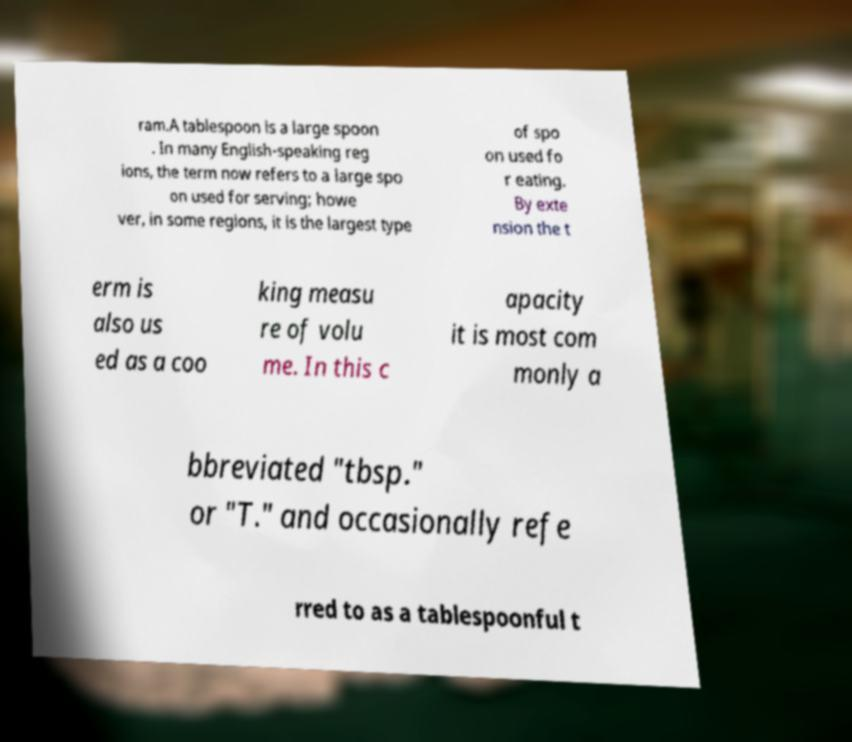Please read and relay the text visible in this image. What does it say? ram.A tablespoon is a large spoon . In many English-speaking reg ions, the term now refers to a large spo on used for serving; howe ver, in some regions, it is the largest type of spo on used fo r eating. By exte nsion the t erm is also us ed as a coo king measu re of volu me. In this c apacity it is most com monly a bbreviated "tbsp." or "T." and occasionally refe rred to as a tablespoonful t 